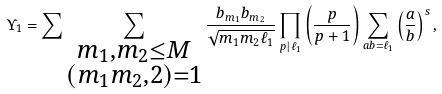Convert formula to latex. <formula><loc_0><loc_0><loc_500><loc_500>\Upsilon _ { 1 } = \sum \sum _ { \substack { m _ { 1 } , m _ { 2 } \leq M \\ ( m _ { 1 } m _ { 2 } , 2 ) = 1 } } \frac { b _ { m _ { 1 } } b _ { m _ { 2 } } } { \sqrt { m _ { 1 } m _ { 2 } \ell _ { 1 } } } \prod _ { p | \ell _ { 1 } } \left ( \frac { p } { p + 1 } \right ) \sum _ { a b = \ell _ { 1 } } \left ( \frac { a } { b } \right ) ^ { s } ,</formula> 